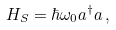<formula> <loc_0><loc_0><loc_500><loc_500>H _ { S } = \hbar { \omega } _ { 0 } a ^ { \dagger } a \, ,</formula> 